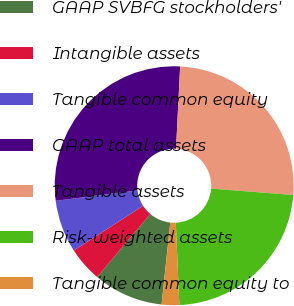Convert chart to OTSL. <chart><loc_0><loc_0><loc_500><loc_500><pie_chart><fcel>GAAP SVBFG stockholders'<fcel>Intangible assets<fcel>Tangible common equity<fcel>GAAP total assets<fcel>Tangible assets<fcel>Risk-weighted assets<fcel>Tangible common equity to<nl><fcel>9.47%<fcel>4.73%<fcel>7.1%<fcel>27.81%<fcel>25.44%<fcel>23.08%<fcel>2.37%<nl></chart> 